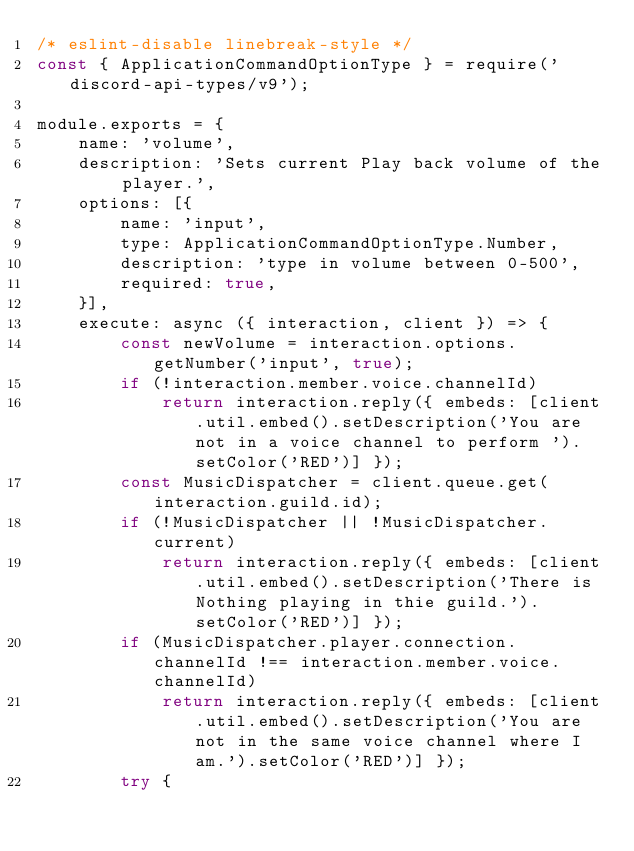Convert code to text. <code><loc_0><loc_0><loc_500><loc_500><_JavaScript_>/* eslint-disable linebreak-style */
const { ApplicationCommandOptionType } = require('discord-api-types/v9');

module.exports = {
    name: 'volume',
    description: 'Sets current Play back volume of the player.',
    options: [{
        name: 'input',
        type: ApplicationCommandOptionType.Number,
        description: 'type in volume between 0-500',
        required: true,
    }],
    execute: async ({ interaction, client }) => {
        const newVolume = interaction.options.getNumber('input', true);
        if (!interaction.member.voice.channelId)
            return interaction.reply({ embeds: [client.util.embed().setDescription('You are not in a voice channel to perform ').setColor('RED')] });
        const MusicDispatcher = client.queue.get(interaction.guild.id);
        if (!MusicDispatcher || !MusicDispatcher.current)
            return interaction.reply({ embeds: [client.util.embed().setDescription('There is Nothing playing in thie guild.').setColor('RED')] });
        if (MusicDispatcher.player.connection.channelId !== interaction.member.voice.channelId)
            return interaction.reply({ embeds: [client.util.embed().setDescription('You are not in the same voice channel where I am.').setColor('RED')] });
        try {</code> 